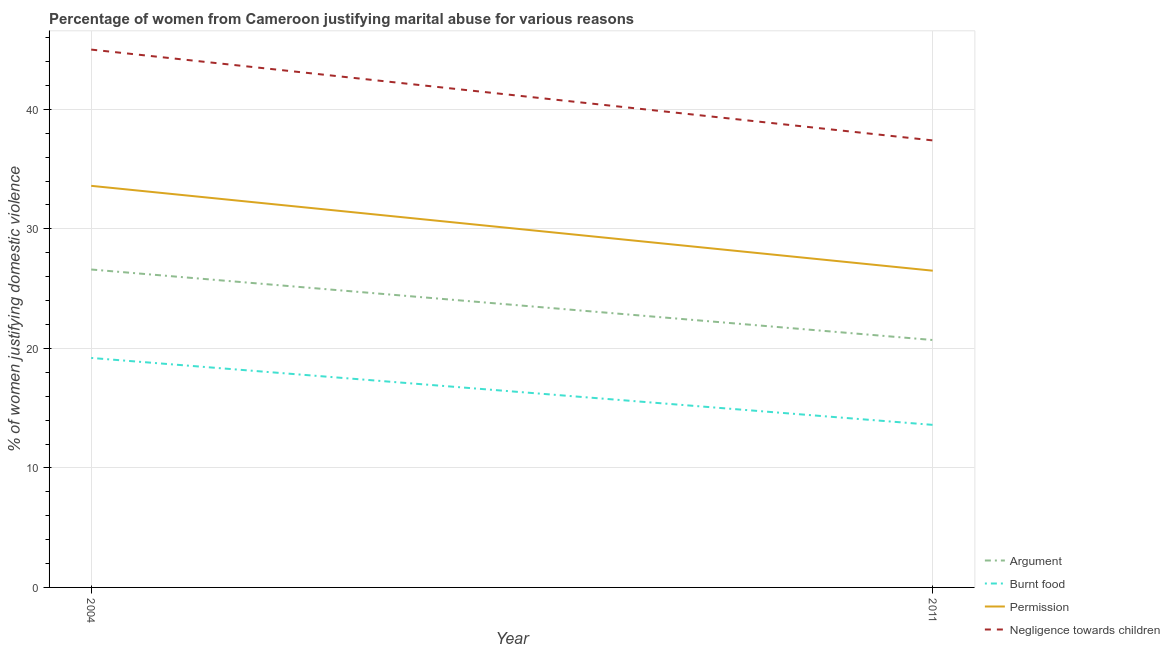Does the line corresponding to percentage of women justifying abuse in the case of an argument intersect with the line corresponding to percentage of women justifying abuse for going without permission?
Give a very brief answer. No. What is the percentage of women justifying abuse for burning food in 2011?
Your response must be concise. 13.6. In which year was the percentage of women justifying abuse for burning food maximum?
Offer a terse response. 2004. In which year was the percentage of women justifying abuse in the case of an argument minimum?
Your answer should be very brief. 2011. What is the total percentage of women justifying abuse for burning food in the graph?
Your answer should be very brief. 32.8. What is the difference between the percentage of women justifying abuse for going without permission in 2004 and that in 2011?
Keep it short and to the point. 7.1. What is the difference between the percentage of women justifying abuse in the case of an argument in 2011 and the percentage of women justifying abuse for burning food in 2004?
Provide a short and direct response. 1.5. What is the average percentage of women justifying abuse for showing negligence towards children per year?
Provide a short and direct response. 41.2. In the year 2011, what is the difference between the percentage of women justifying abuse for showing negligence towards children and percentage of women justifying abuse for going without permission?
Provide a succinct answer. 10.9. What is the ratio of the percentage of women justifying abuse in the case of an argument in 2004 to that in 2011?
Offer a very short reply. 1.29. Is it the case that in every year, the sum of the percentage of women justifying abuse for going without permission and percentage of women justifying abuse for showing negligence towards children is greater than the sum of percentage of women justifying abuse for burning food and percentage of women justifying abuse in the case of an argument?
Ensure brevity in your answer.  Yes. Is it the case that in every year, the sum of the percentage of women justifying abuse in the case of an argument and percentage of women justifying abuse for burning food is greater than the percentage of women justifying abuse for going without permission?
Your answer should be compact. Yes. Is the percentage of women justifying abuse for showing negligence towards children strictly less than the percentage of women justifying abuse for burning food over the years?
Give a very brief answer. No. How many lines are there?
Provide a succinct answer. 4. What is the difference between two consecutive major ticks on the Y-axis?
Keep it short and to the point. 10. Are the values on the major ticks of Y-axis written in scientific E-notation?
Provide a short and direct response. No. Does the graph contain grids?
Make the answer very short. Yes. Where does the legend appear in the graph?
Give a very brief answer. Bottom right. How are the legend labels stacked?
Your answer should be compact. Vertical. What is the title of the graph?
Make the answer very short. Percentage of women from Cameroon justifying marital abuse for various reasons. Does "France" appear as one of the legend labels in the graph?
Offer a terse response. No. What is the label or title of the X-axis?
Offer a terse response. Year. What is the label or title of the Y-axis?
Ensure brevity in your answer.  % of women justifying domestic violence. What is the % of women justifying domestic violence in Argument in 2004?
Offer a very short reply. 26.6. What is the % of women justifying domestic violence of Burnt food in 2004?
Give a very brief answer. 19.2. What is the % of women justifying domestic violence of Permission in 2004?
Your response must be concise. 33.6. What is the % of women justifying domestic violence of Argument in 2011?
Give a very brief answer. 20.7. What is the % of women justifying domestic violence of Burnt food in 2011?
Make the answer very short. 13.6. What is the % of women justifying domestic violence of Negligence towards children in 2011?
Offer a very short reply. 37.4. Across all years, what is the maximum % of women justifying domestic violence in Argument?
Provide a short and direct response. 26.6. Across all years, what is the maximum % of women justifying domestic violence of Permission?
Ensure brevity in your answer.  33.6. Across all years, what is the maximum % of women justifying domestic violence in Negligence towards children?
Offer a very short reply. 45. Across all years, what is the minimum % of women justifying domestic violence of Argument?
Give a very brief answer. 20.7. Across all years, what is the minimum % of women justifying domestic violence of Burnt food?
Make the answer very short. 13.6. Across all years, what is the minimum % of women justifying domestic violence in Negligence towards children?
Provide a succinct answer. 37.4. What is the total % of women justifying domestic violence in Argument in the graph?
Give a very brief answer. 47.3. What is the total % of women justifying domestic violence in Burnt food in the graph?
Offer a very short reply. 32.8. What is the total % of women justifying domestic violence of Permission in the graph?
Make the answer very short. 60.1. What is the total % of women justifying domestic violence in Negligence towards children in the graph?
Keep it short and to the point. 82.4. What is the difference between the % of women justifying domestic violence in Burnt food in 2004 and that in 2011?
Offer a very short reply. 5.6. What is the difference between the % of women justifying domestic violence of Negligence towards children in 2004 and that in 2011?
Provide a short and direct response. 7.6. What is the difference between the % of women justifying domestic violence of Argument in 2004 and the % of women justifying domestic violence of Negligence towards children in 2011?
Make the answer very short. -10.8. What is the difference between the % of women justifying domestic violence of Burnt food in 2004 and the % of women justifying domestic violence of Negligence towards children in 2011?
Offer a terse response. -18.2. What is the difference between the % of women justifying domestic violence in Permission in 2004 and the % of women justifying domestic violence in Negligence towards children in 2011?
Your answer should be very brief. -3.8. What is the average % of women justifying domestic violence in Argument per year?
Offer a very short reply. 23.65. What is the average % of women justifying domestic violence in Permission per year?
Keep it short and to the point. 30.05. What is the average % of women justifying domestic violence in Negligence towards children per year?
Your response must be concise. 41.2. In the year 2004, what is the difference between the % of women justifying domestic violence in Argument and % of women justifying domestic violence in Burnt food?
Offer a very short reply. 7.4. In the year 2004, what is the difference between the % of women justifying domestic violence of Argument and % of women justifying domestic violence of Permission?
Keep it short and to the point. -7. In the year 2004, what is the difference between the % of women justifying domestic violence in Argument and % of women justifying domestic violence in Negligence towards children?
Provide a short and direct response. -18.4. In the year 2004, what is the difference between the % of women justifying domestic violence of Burnt food and % of women justifying domestic violence of Permission?
Your response must be concise. -14.4. In the year 2004, what is the difference between the % of women justifying domestic violence of Burnt food and % of women justifying domestic violence of Negligence towards children?
Your answer should be very brief. -25.8. In the year 2004, what is the difference between the % of women justifying domestic violence of Permission and % of women justifying domestic violence of Negligence towards children?
Make the answer very short. -11.4. In the year 2011, what is the difference between the % of women justifying domestic violence of Argument and % of women justifying domestic violence of Burnt food?
Offer a terse response. 7.1. In the year 2011, what is the difference between the % of women justifying domestic violence in Argument and % of women justifying domestic violence in Negligence towards children?
Offer a terse response. -16.7. In the year 2011, what is the difference between the % of women justifying domestic violence in Burnt food and % of women justifying domestic violence in Negligence towards children?
Make the answer very short. -23.8. What is the ratio of the % of women justifying domestic violence of Argument in 2004 to that in 2011?
Provide a succinct answer. 1.28. What is the ratio of the % of women justifying domestic violence in Burnt food in 2004 to that in 2011?
Provide a short and direct response. 1.41. What is the ratio of the % of women justifying domestic violence of Permission in 2004 to that in 2011?
Your answer should be compact. 1.27. What is the ratio of the % of women justifying domestic violence of Negligence towards children in 2004 to that in 2011?
Your answer should be very brief. 1.2. What is the difference between the highest and the second highest % of women justifying domestic violence in Burnt food?
Provide a short and direct response. 5.6. What is the difference between the highest and the second highest % of women justifying domestic violence in Negligence towards children?
Your response must be concise. 7.6. 